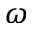<formula> <loc_0><loc_0><loc_500><loc_500>\omega</formula> 